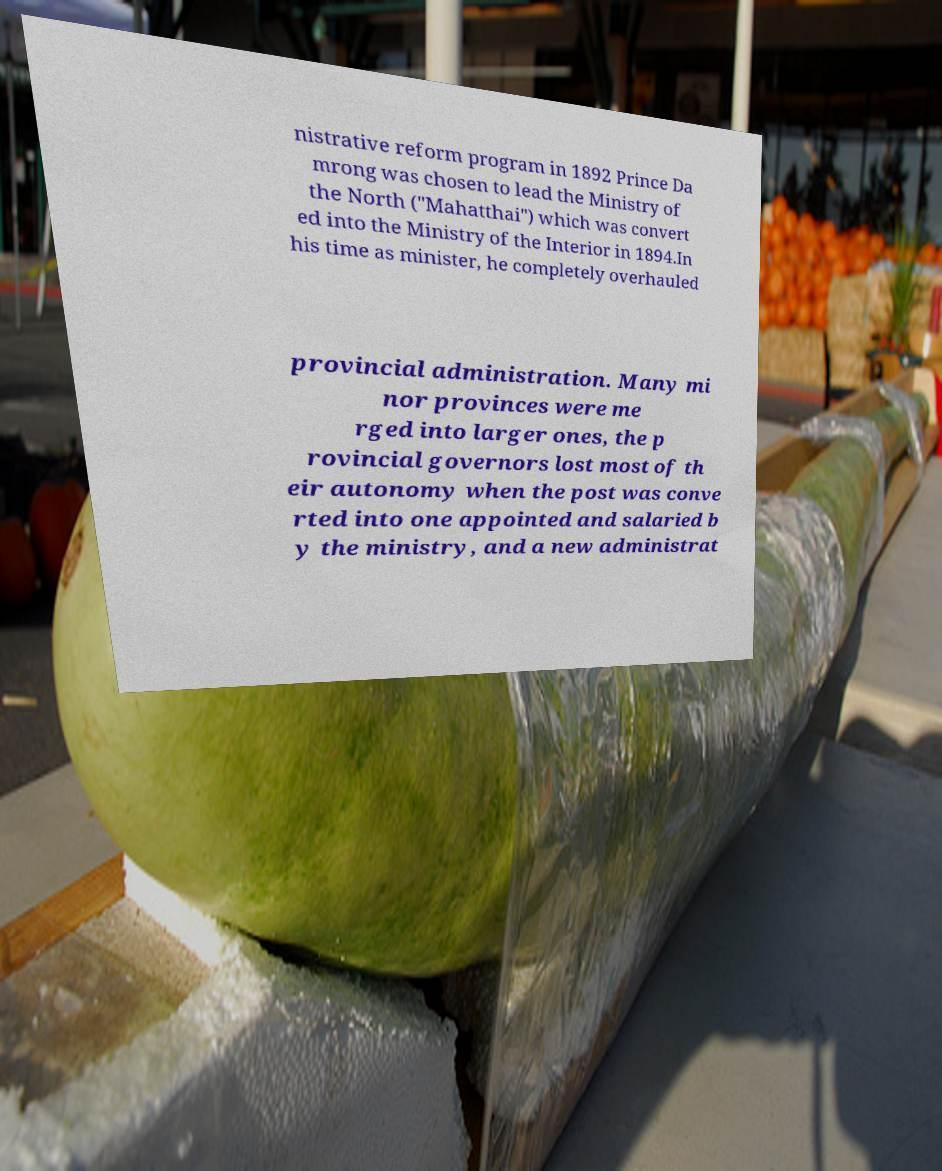What messages or text are displayed in this image? I need them in a readable, typed format. nistrative reform program in 1892 Prince Da mrong was chosen to lead the Ministry of the North ("Mahatthai") which was convert ed into the Ministry of the Interior in 1894.In his time as minister, he completely overhauled provincial administration. Many mi nor provinces were me rged into larger ones, the p rovincial governors lost most of th eir autonomy when the post was conve rted into one appointed and salaried b y the ministry, and a new administrat 